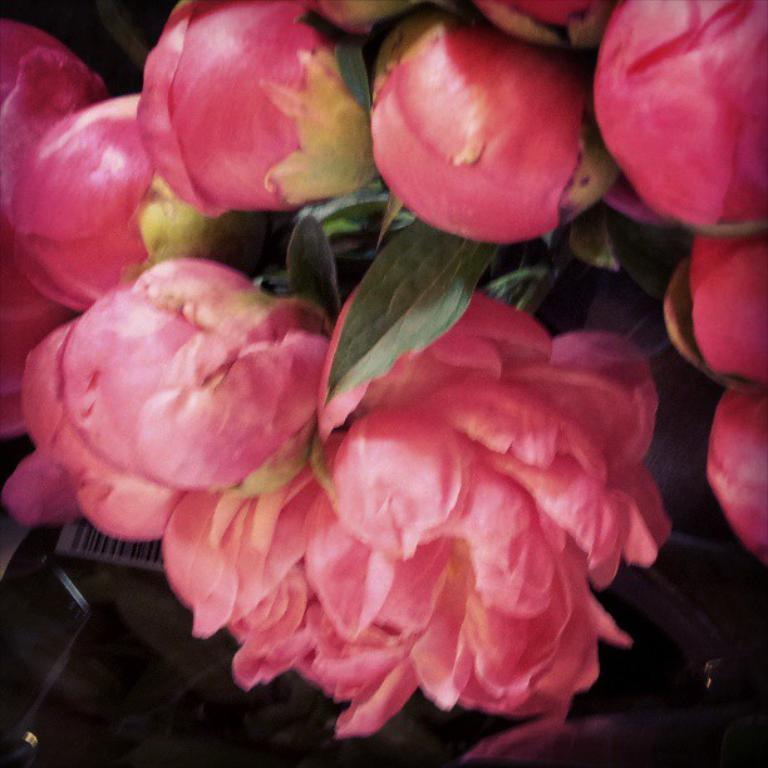What type of flowers can be seen in the image? There are pink flowers in the image. What stage of growth are some of the flowers in? There are buds in the image. What color are the leaves in the image? There are green leaves in the image. What type of drink is being served with a straw in the image? There is no drink or straw present in the image; it features pink flowers, buds, and green leaves. How many apples are visible in the image? There are no apples present in the image. 